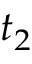Convert formula to latex. <formula><loc_0><loc_0><loc_500><loc_500>t _ { 2 }</formula> 